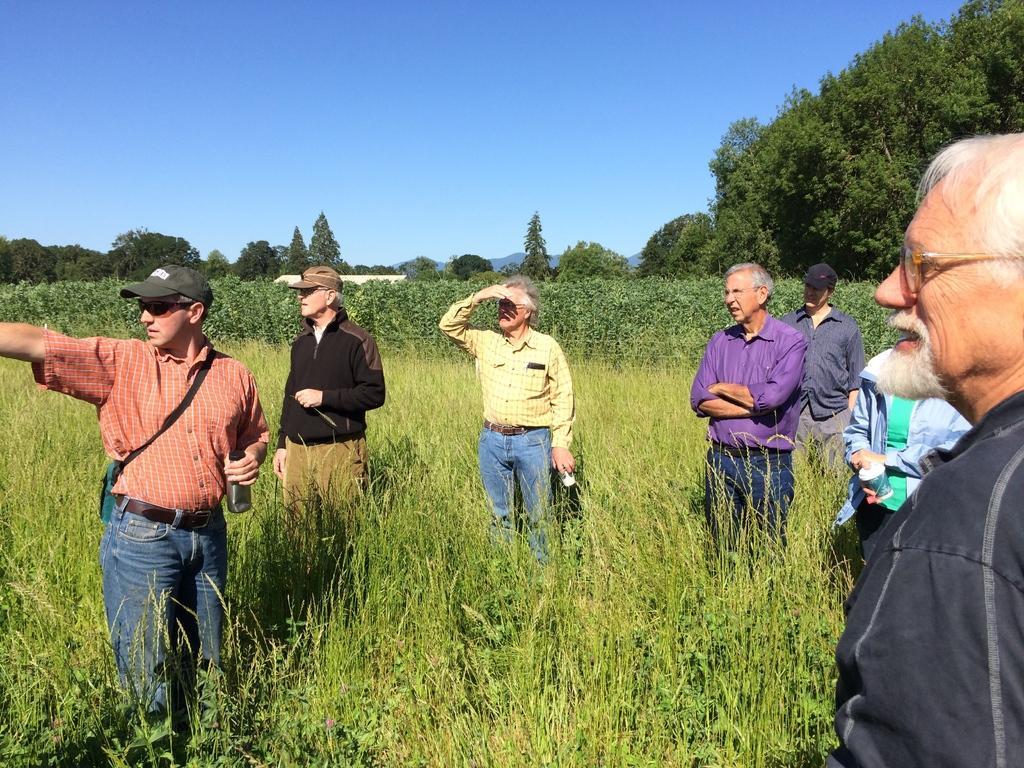Describe this image in one or two sentences. In this image, we can see a group of people are standing. Few are holding some objects. Here there are so many plants and trees. Background there is a clear sky. 